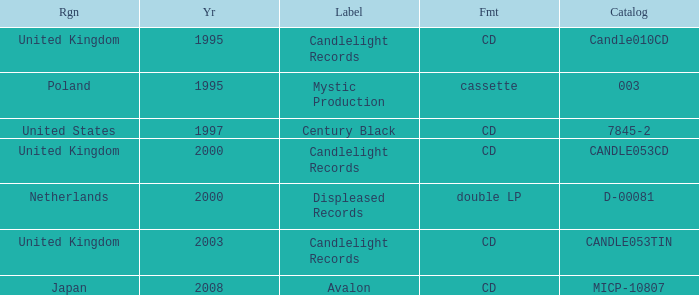What is Candlelight Records format? CD, CD, CD. Parse the table in full. {'header': ['Rgn', 'Yr', 'Label', 'Fmt', 'Catalog'], 'rows': [['United Kingdom', '1995', 'Candlelight Records', 'CD', 'Candle010CD'], ['Poland', '1995', 'Mystic Production', 'cassette', '003'], ['United States', '1997', 'Century Black', 'CD', '7845-2'], ['United Kingdom', '2000', 'Candlelight Records', 'CD', 'CANDLE053CD'], ['Netherlands', '2000', 'Displeased Records', 'double LP', 'D-00081'], ['United Kingdom', '2003', 'Candlelight Records', 'CD', 'CANDLE053TIN'], ['Japan', '2008', 'Avalon', 'CD', 'MICP-10807']]} 